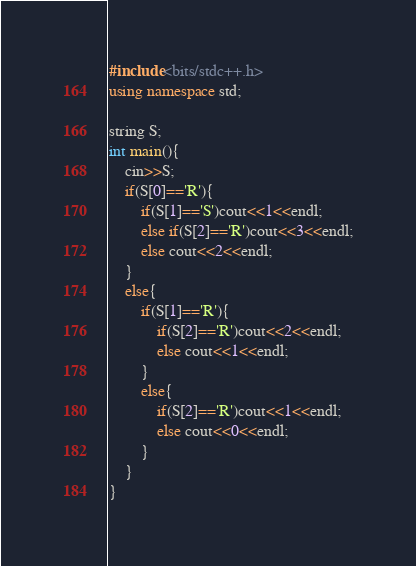Convert code to text. <code><loc_0><loc_0><loc_500><loc_500><_C++_>#include<bits/stdc++.h>
using namespace std;

string S;
int main(){
	cin>>S;
	if(S[0]=='R'){
		if(S[1]=='S')cout<<1<<endl;
		else if(S[2]=='R')cout<<3<<endl;
		else cout<<2<<endl;
	}
	else{
		if(S[1]=='R'){
			if(S[2]=='R')cout<<2<<endl;
			else cout<<1<<endl;
		}
		else{
			if(S[2]=='R')cout<<1<<endl;
			else cout<<0<<endl;
		}
	}
}</code> 